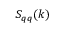Convert formula to latex. <formula><loc_0><loc_0><loc_500><loc_500>S _ { q q } ( k )</formula> 